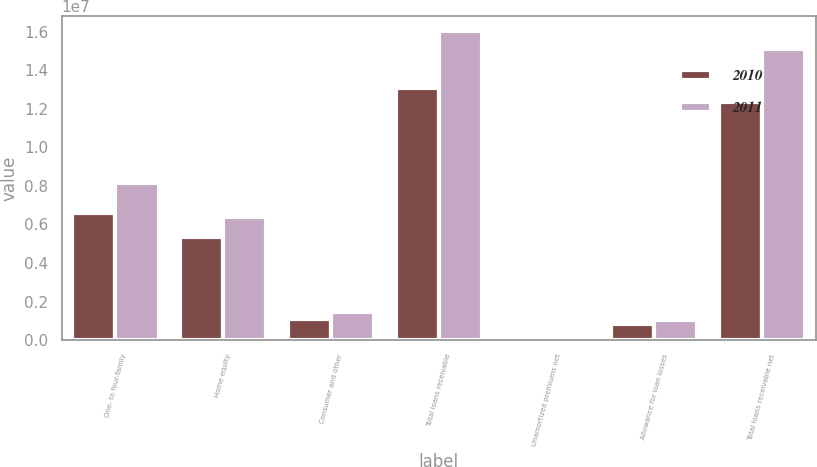Convert chart. <chart><loc_0><loc_0><loc_500><loc_500><stacked_bar_chart><ecel><fcel>One- to four-family<fcel>Home equity<fcel>Consumer and other<fcel>Total loans receivable<fcel>Unamortized premiums net<fcel>Allowance for loan losses<fcel>Total loans receivable net<nl><fcel>2010<fcel>6.61581e+06<fcel>5.32866e+06<fcel>1.11326e+06<fcel>1.30577e+07<fcel>97901<fcel>822816<fcel>1.23328e+07<nl><fcel>2011<fcel>8.17033e+06<fcel>6.41031e+06<fcel>1.4434e+06<fcel>1.6024e+07<fcel>129050<fcel>1.03117e+06<fcel>1.51219e+07<nl></chart> 